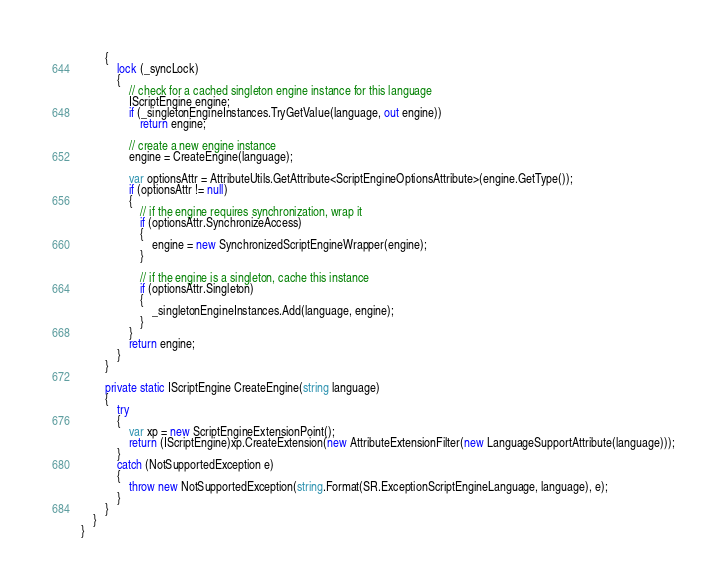Convert code to text. <code><loc_0><loc_0><loc_500><loc_500><_C#_>		{
			lock (_syncLock)
			{
				// check for a cached singleton engine instance for this language
				IScriptEngine engine;
				if (_singletonEngineInstances.TryGetValue(language, out engine))
					return engine;

				// create a new engine instance
				engine = CreateEngine(language);

				var optionsAttr = AttributeUtils.GetAttribute<ScriptEngineOptionsAttribute>(engine.GetType());
				if (optionsAttr != null)
				{
					// if the engine requires synchronization, wrap it
					if (optionsAttr.SynchronizeAccess)
					{
						engine = new SynchronizedScriptEngineWrapper(engine);
					}

					// if the engine is a singleton, cache this instance
					if (optionsAttr.Singleton)
					{
						_singletonEngineInstances.Add(language, engine);
					}
				}
				return engine;
			}
		}

		private static IScriptEngine CreateEngine(string language)
		{
			try
			{
				var xp = new ScriptEngineExtensionPoint();
				return (IScriptEngine)xp.CreateExtension(new AttributeExtensionFilter(new LanguageSupportAttribute(language)));
			}
			catch (NotSupportedException e)
			{
				throw new NotSupportedException(string.Format(SR.ExceptionScriptEngineLanguage, language), e);
			}
		}
	}
}
</code> 